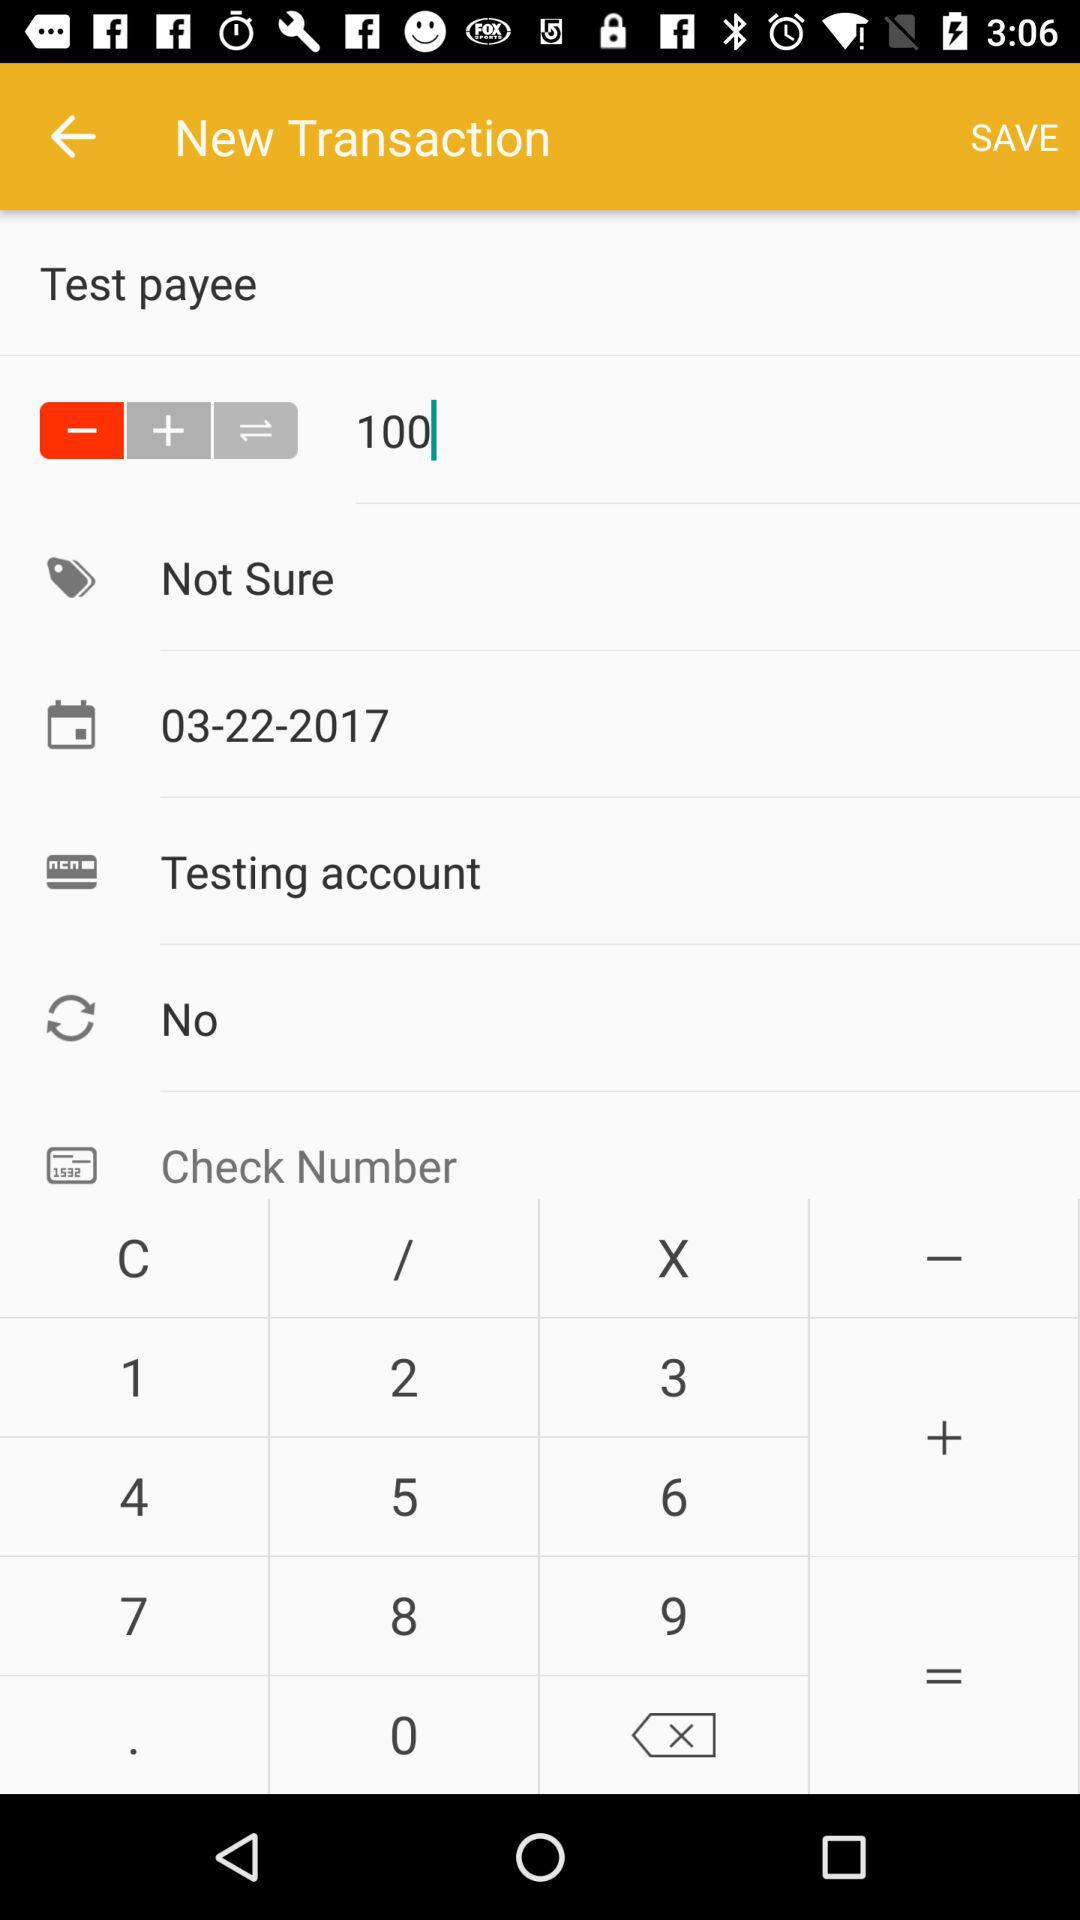What is the value of the amount field?
Answer the question using a single word or phrase. 100 